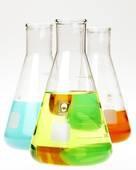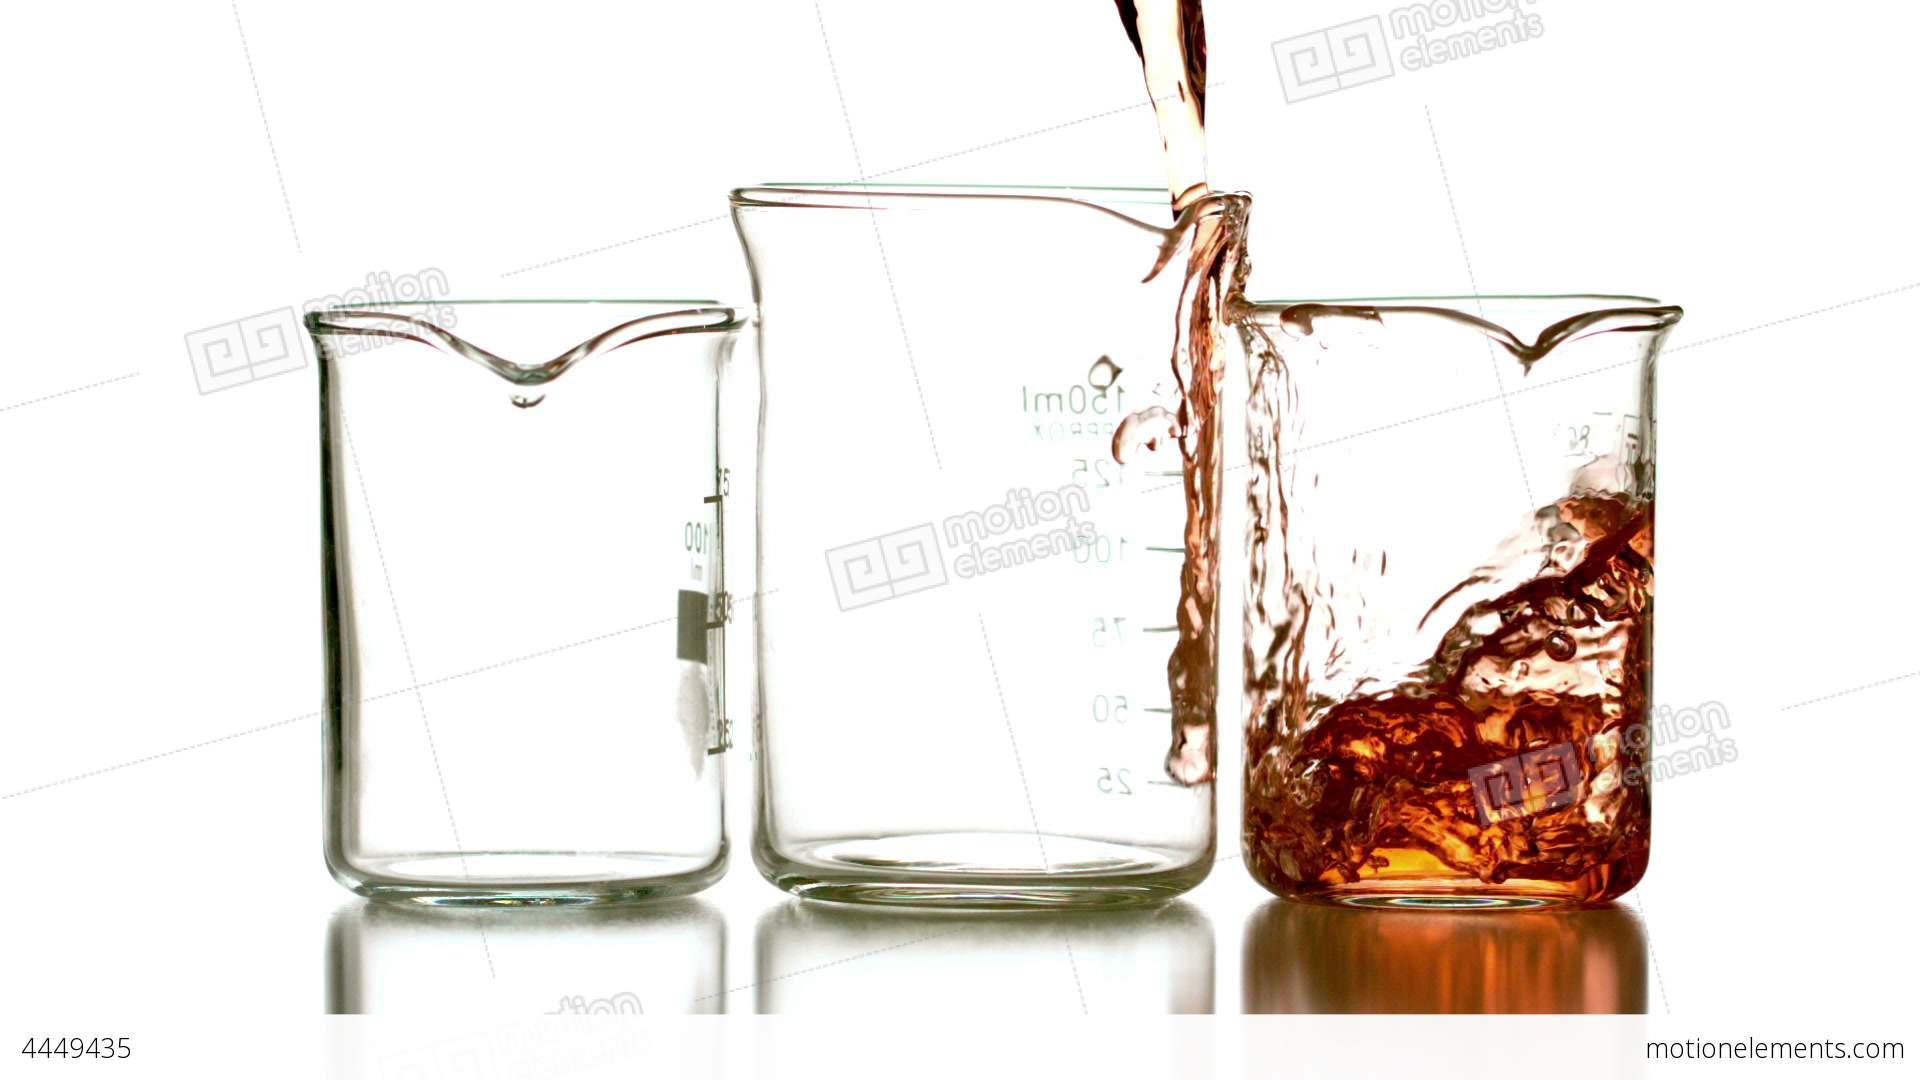The first image is the image on the left, the second image is the image on the right. Considering the images on both sides, is "There are substances in three containers in the image on the left." valid? Answer yes or no. Yes. The first image is the image on the left, the second image is the image on the right. Evaluate the accuracy of this statement regarding the images: "One image shows colored liquid pouring into a glass, and the image contains just one glass.". Is it true? Answer yes or no. No. 